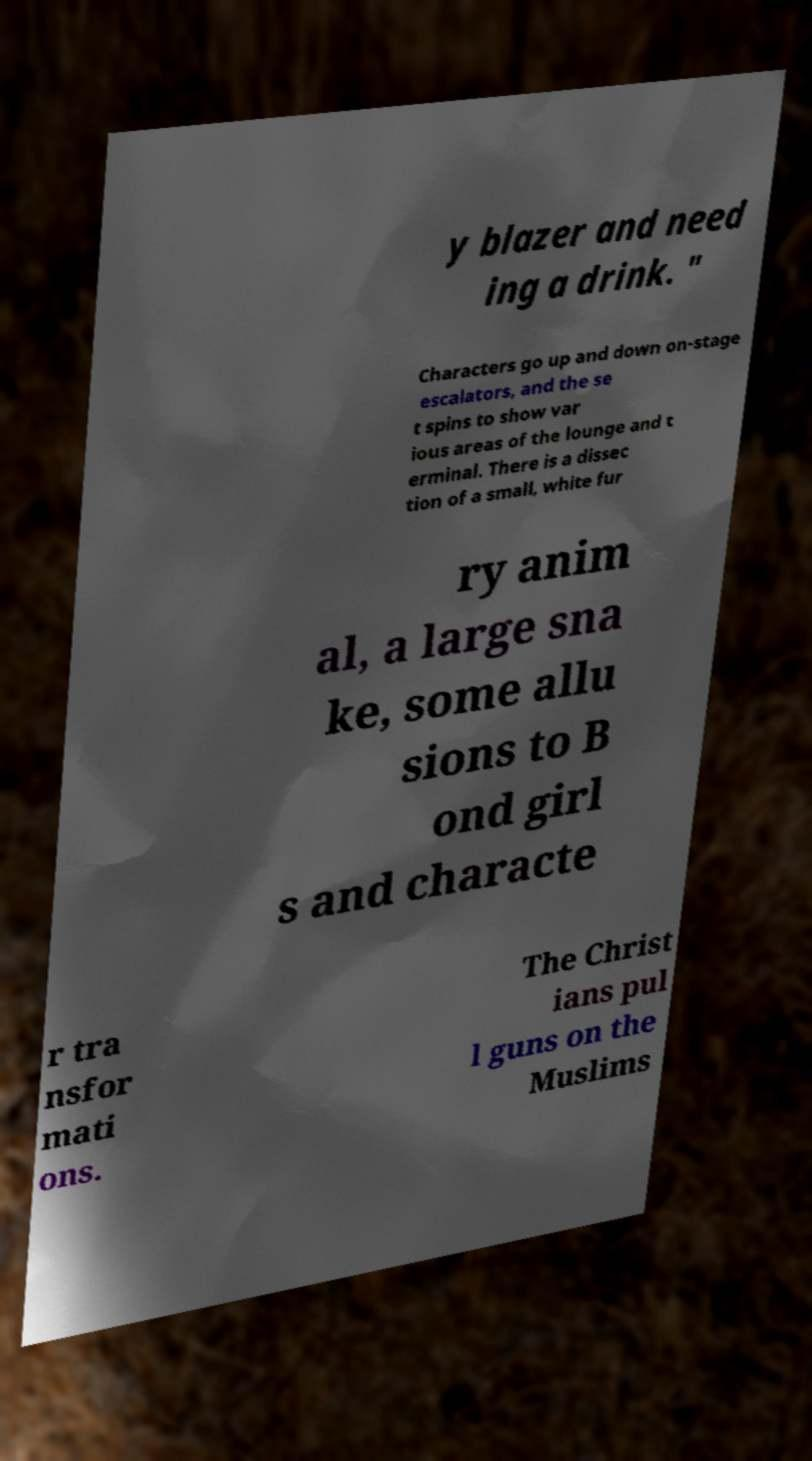Can you accurately transcribe the text from the provided image for me? y blazer and need ing a drink. " Characters go up and down on-stage escalators, and the se t spins to show var ious areas of the lounge and t erminal. There is a dissec tion of a small, white fur ry anim al, a large sna ke, some allu sions to B ond girl s and characte r tra nsfor mati ons. The Christ ians pul l guns on the Muslims 